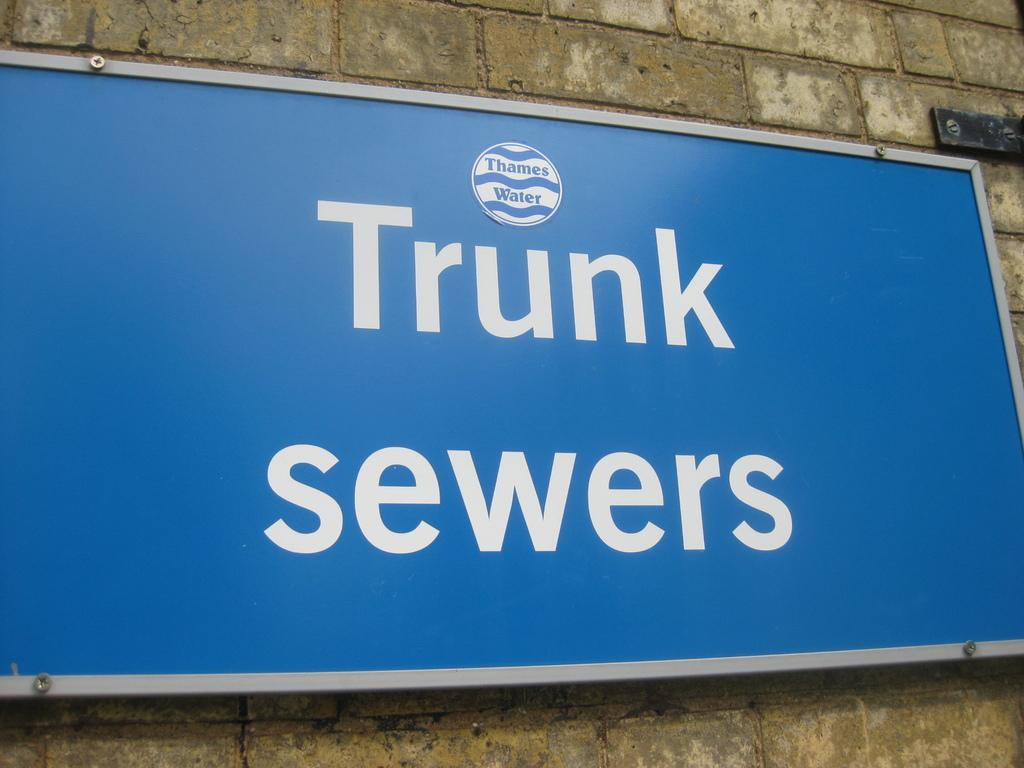<image>
Write a terse but informative summary of the picture. Sign on the wall that says Trunk Sewers in blue background. 